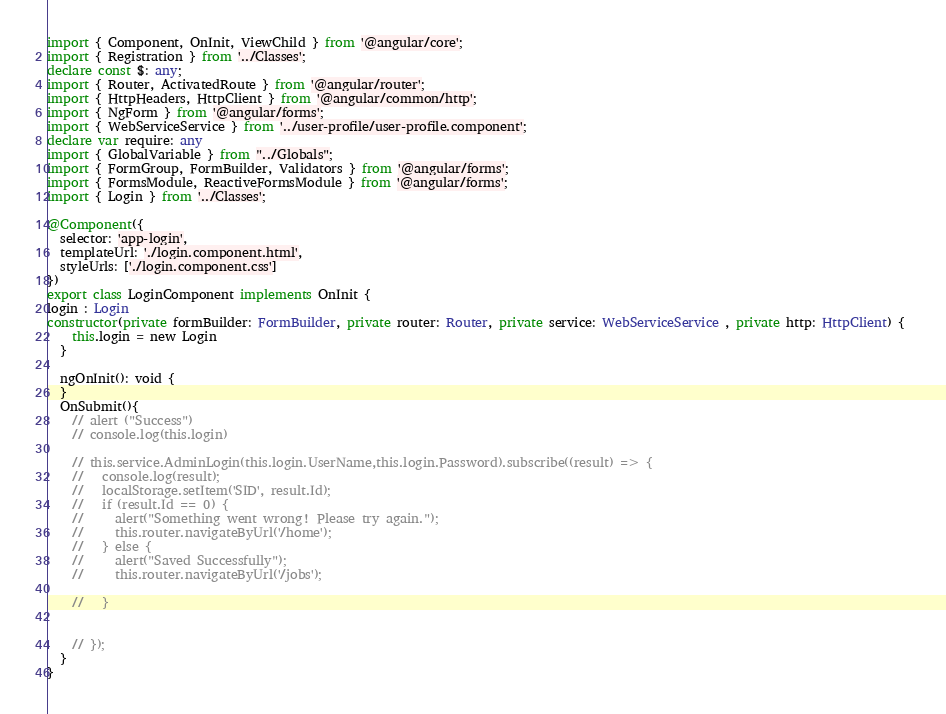<code> <loc_0><loc_0><loc_500><loc_500><_TypeScript_>import { Component, OnInit, ViewChild } from '@angular/core';
import { Registration } from '../Classes';
declare const $: any;
import { Router, ActivatedRoute } from '@angular/router';
import { HttpHeaders, HttpClient } from '@angular/common/http';
import { NgForm } from '@angular/forms';
import { WebServiceService } from '../user-profile/user-profile.component';
declare var require: any
import { GlobalVariable } from "../Globals";
import { FormGroup, FormBuilder, Validators } from '@angular/forms';
import { FormsModule, ReactiveFormsModule } from '@angular/forms';
import { Login } from '../Classes';

@Component({
  selector: 'app-login',
  templateUrl: './login.component.html',
  styleUrls: ['./login.component.css']
})
export class LoginComponent implements OnInit {
login : Login
constructor(private formBuilder: FormBuilder, private router: Router, private service: WebServiceService , private http: HttpClient) { 
    this.login = new Login
  }

  ngOnInit(): void {
  }
  OnSubmit(){
    // alert ("Success")
    // console.log(this.login)

    // this.service.AdminLogin(this.login.UserName,this.login.Password).subscribe((result) => {
    //   console.log(result);
    //   localStorage.setItem('SID', result.Id);
    //   if (result.Id == 0) {
    //     alert("Something went wrong! Please try again.");
    //     this.router.navigateByUrl('/home');
    //   } else {
    //     alert("Saved Successfully");
    //     this.router.navigateByUrl('/jobs');
        
    //   }
    
      
    // });
  }
}


</code> 